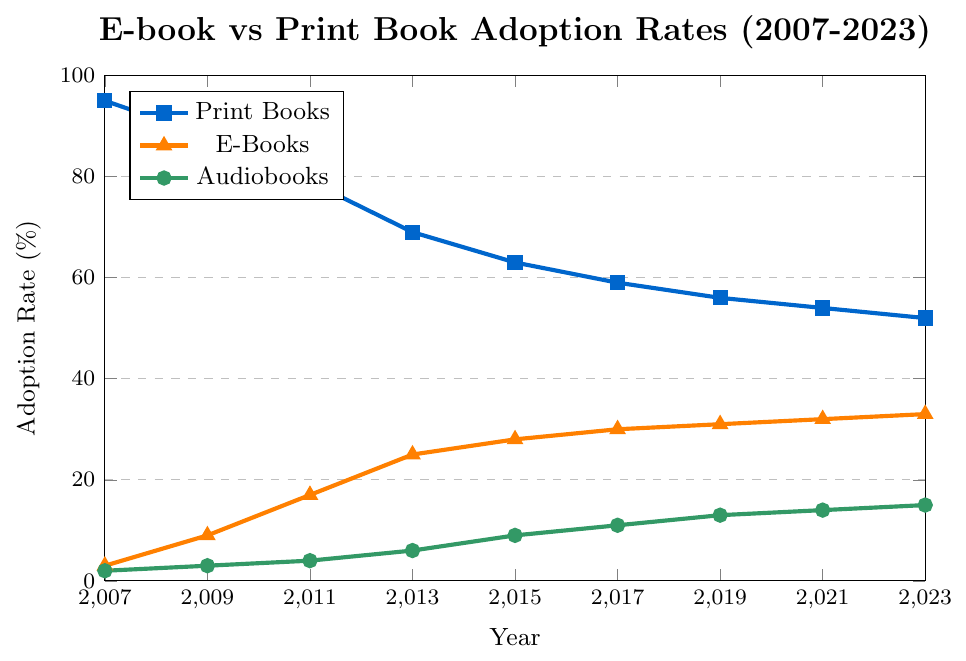What's the highest adoption rate for e-books throughout the years? By looking at the e-books data points plotted in orange triangles, the highest adoption rate occurs at the year 2023 with an adoption rate of 33%.
Answer: 33% How did the adoption rate of print books change from 2007 to 2023? To understand the change, subtract the adoption rate of print books in 2023 (52%) from that in 2007 (95%). The change is 95% - 52% = 43%.
Answer: Decreased by 43% In which years did audiobooks see an adoption rate increase of 2% or more compared to the previous data point? By examining the green circles representing audiobooks, the years with an increase of 2% or more are 2013 (from 4% to 6%), 2015 (from 6% to 9%), and 2017 (from 9% to 11%).
Answer: 2013, 2015, 2017 What's the average adoption rate of print books from 2007 to 2023? First, sum the adoption rates of print books for all the given years: 95 + 88 + 79 + 69 + 63 + 59 + 56 + 54 + 52 = 615. Then, divide by the number of data points (9 years): 615 / 9 = 68.33%.
Answer: 68.33% What is the sum of the adoption rates for e-books and audiobooks in 2023? By adding the adoption rates of e-books (33%) and audiobooks (15%) for the year 2023, you get 33% + 15% = 48%.
Answer: 48% 